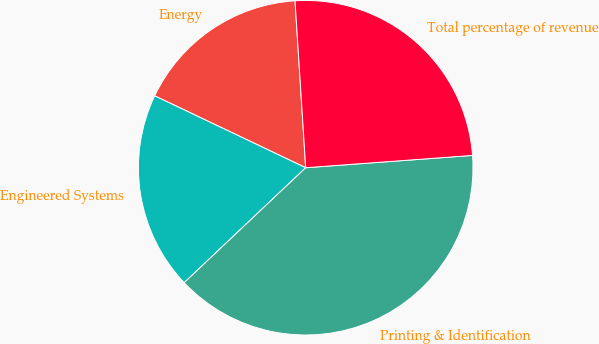Convert chart. <chart><loc_0><loc_0><loc_500><loc_500><pie_chart><fcel>Energy<fcel>Engineered Systems<fcel>Printing & Identification<fcel>Total percentage of revenue<nl><fcel>16.91%<fcel>19.13%<fcel>39.11%<fcel>24.84%<nl></chart> 